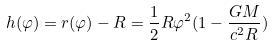<formula> <loc_0><loc_0><loc_500><loc_500>h ( \varphi ) = r ( \varphi ) - R = \frac { 1 } { 2 } R { \varphi } ^ { 2 } ( 1 - \frac { G M } { c ^ { 2 } R } )</formula> 